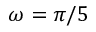Convert formula to latex. <formula><loc_0><loc_0><loc_500><loc_500>\omega = \pi / 5</formula> 